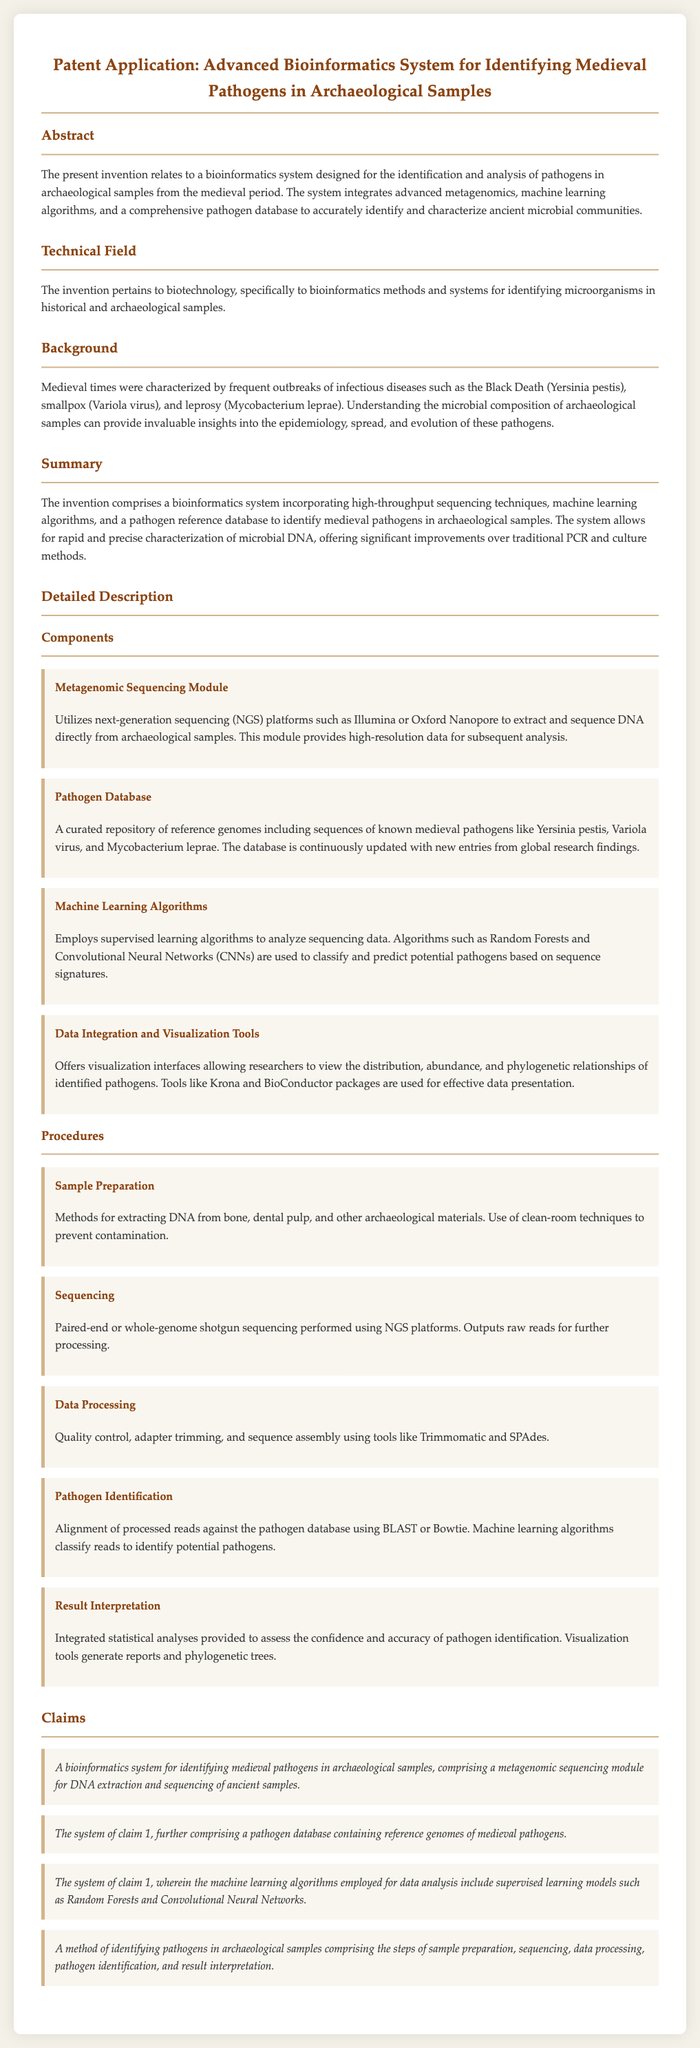What is the title of the patent application? The title is found at the beginning of the document and states the purpose of the application.
Answer: Advanced Bioinformatics System for Identifying Medieval Pathogens in Archaeological Samples What are the pathogens mentioned in the background? The background section lists specific historical pathogens that are of interest in the research.
Answer: Yersinia pestis, Variola virus, Mycobacterium leprae What module uses next-generation sequencing? The detailed description includes components that explain different aspects of the system invented.
Answer: Metagenomic Sequencing Module What type of algorithms are employed for data analysis? The document includes information about the techniques used in the invention's methods.
Answer: Supervised learning What is the first step in the procedure for identifying pathogens? The section on procedures outlines the steps necessary to identify pathogens in archaeological samples.
Answer: Sample Preparation What is a tool mentioned for statistic analysis and visualization? The document lists specific tools used in the data processing and visualization stage of the invention.
Answer: BioConductor packages What does the inventive system improve upon? The summary section describes advantages the invention has over previous methods.
Answer: Traditional PCR and culture methods How many claims are made in this patent application? The number of claims is explicitly stated in the claims section of the document.
Answer: Four 